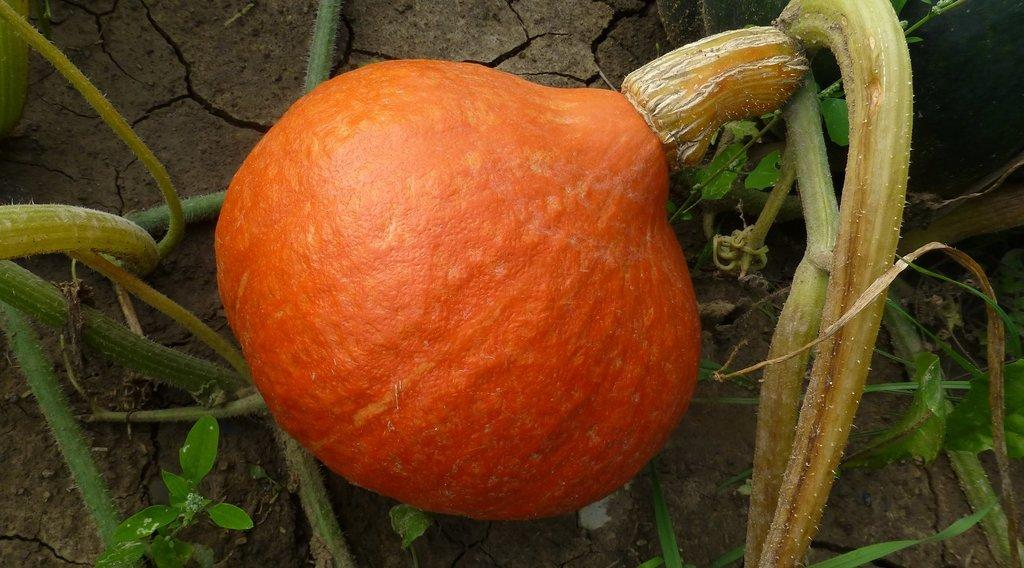What is the main object in the image? There is a pumpkin on a plant in the image. Where is the pumpkin located? The pumpkin is on the land. Are there any other plants visible in the image? Yes, there are other plants on the land. What type of apples can be seen growing on the pumpkin plant in the image? There are no apples present in the image; it features a pumpkin on a plant. Can you describe the fireman running towards the pumpkin in the image? There is no fireman or running depicted in the image. 